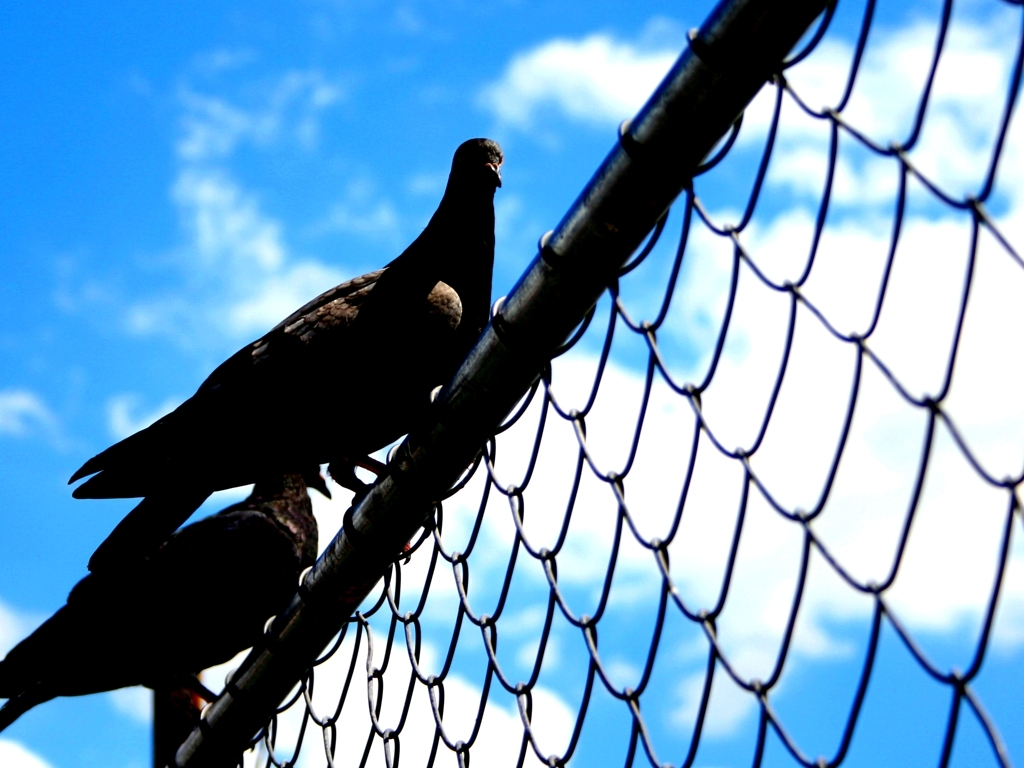Are the details of the wire fence accurately presented? Yes, the image depicts the details of the wire fence with clarity and precision. The symmetry of the hexagonal mesh pattern is clearly visible against the bright blue sky, and each individual wire intersection is sharply defined, demonstrating the photo's capability to capture intricate textures and patterns. 